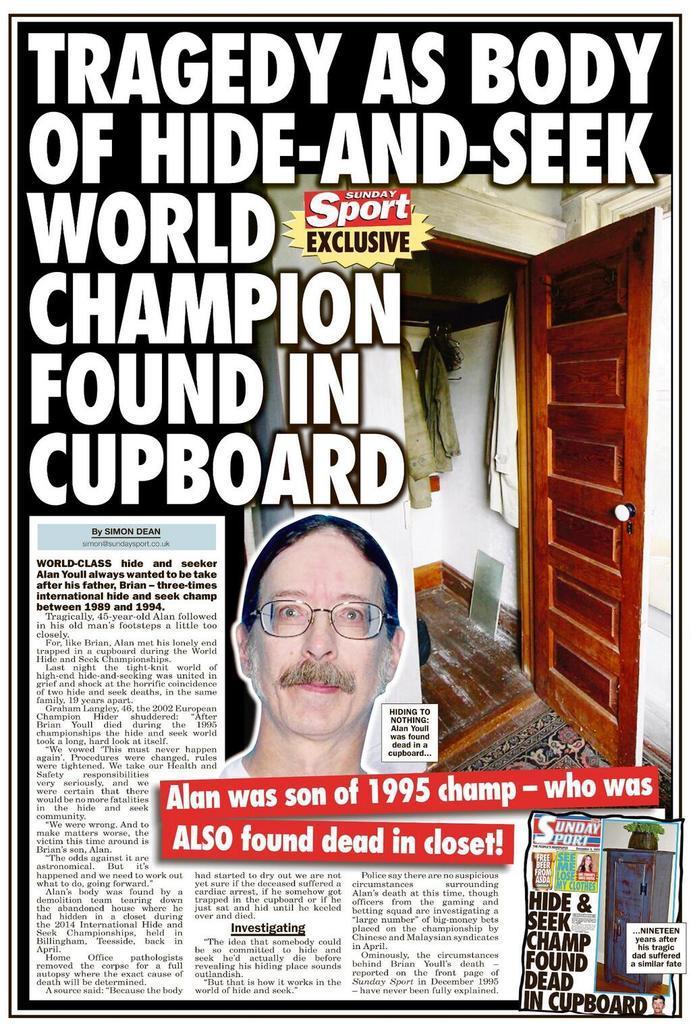Please provide a concise description of this image. Something written on this poster. On this poster we can see door, clothes and person picture. 